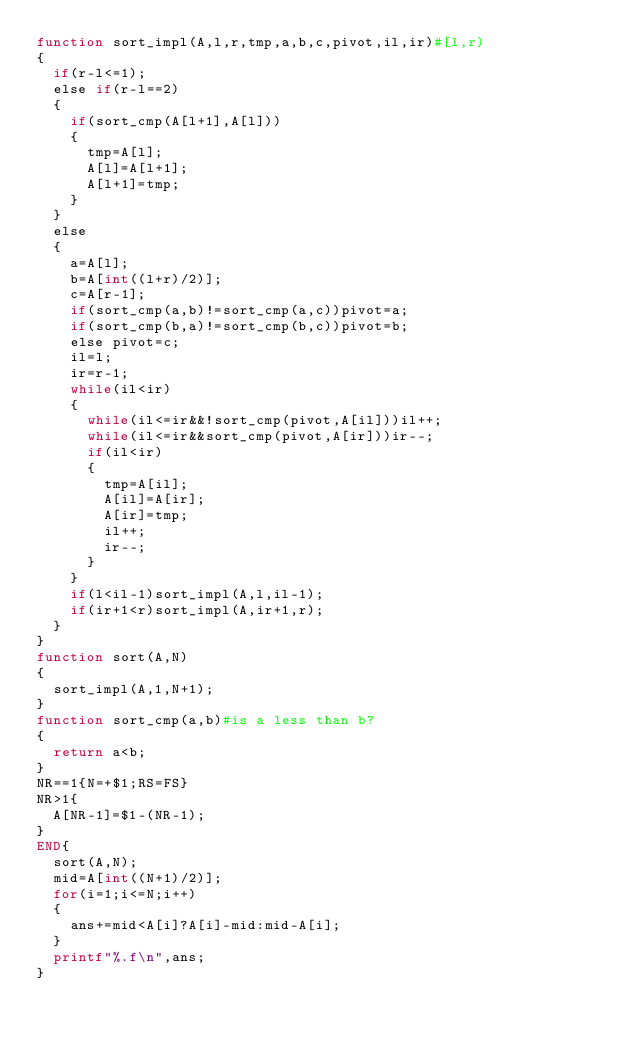Convert code to text. <code><loc_0><loc_0><loc_500><loc_500><_Awk_>function sort_impl(A,l,r,tmp,a,b,c,pivot,il,ir)#[l,r)
{
	if(r-l<=1);
	else if(r-l==2)
	{
		if(sort_cmp(A[l+1],A[l]))
		{
			tmp=A[l];
			A[l]=A[l+1];
			A[l+1]=tmp;
		}
	}
	else
	{
		a=A[l];
		b=A[int((l+r)/2)];
		c=A[r-1];
		if(sort_cmp(a,b)!=sort_cmp(a,c))pivot=a;
		if(sort_cmp(b,a)!=sort_cmp(b,c))pivot=b;
		else pivot=c;
		il=l;
		ir=r-1;
		while(il<ir)
		{
			while(il<=ir&&!sort_cmp(pivot,A[il]))il++;
			while(il<=ir&&sort_cmp(pivot,A[ir]))ir--;
			if(il<ir)
			{
				tmp=A[il];
				A[il]=A[ir];
				A[ir]=tmp;
				il++;
				ir--;
			}
		}
		if(l<il-1)sort_impl(A,l,il-1);
		if(ir+1<r)sort_impl(A,ir+1,r);
	}
}
function sort(A,N)
{
	sort_impl(A,1,N+1);
}
function sort_cmp(a,b)#is a less than b?
{
	return a<b;
}
NR==1{N=+$1;RS=FS}
NR>1{
	A[NR-1]=$1-(NR-1);
}
END{
	sort(A,N);
	mid=A[int((N+1)/2)];
	for(i=1;i<=N;i++)
	{
		ans+=mid<A[i]?A[i]-mid:mid-A[i];
	}
	printf"%.f\n",ans;
}</code> 